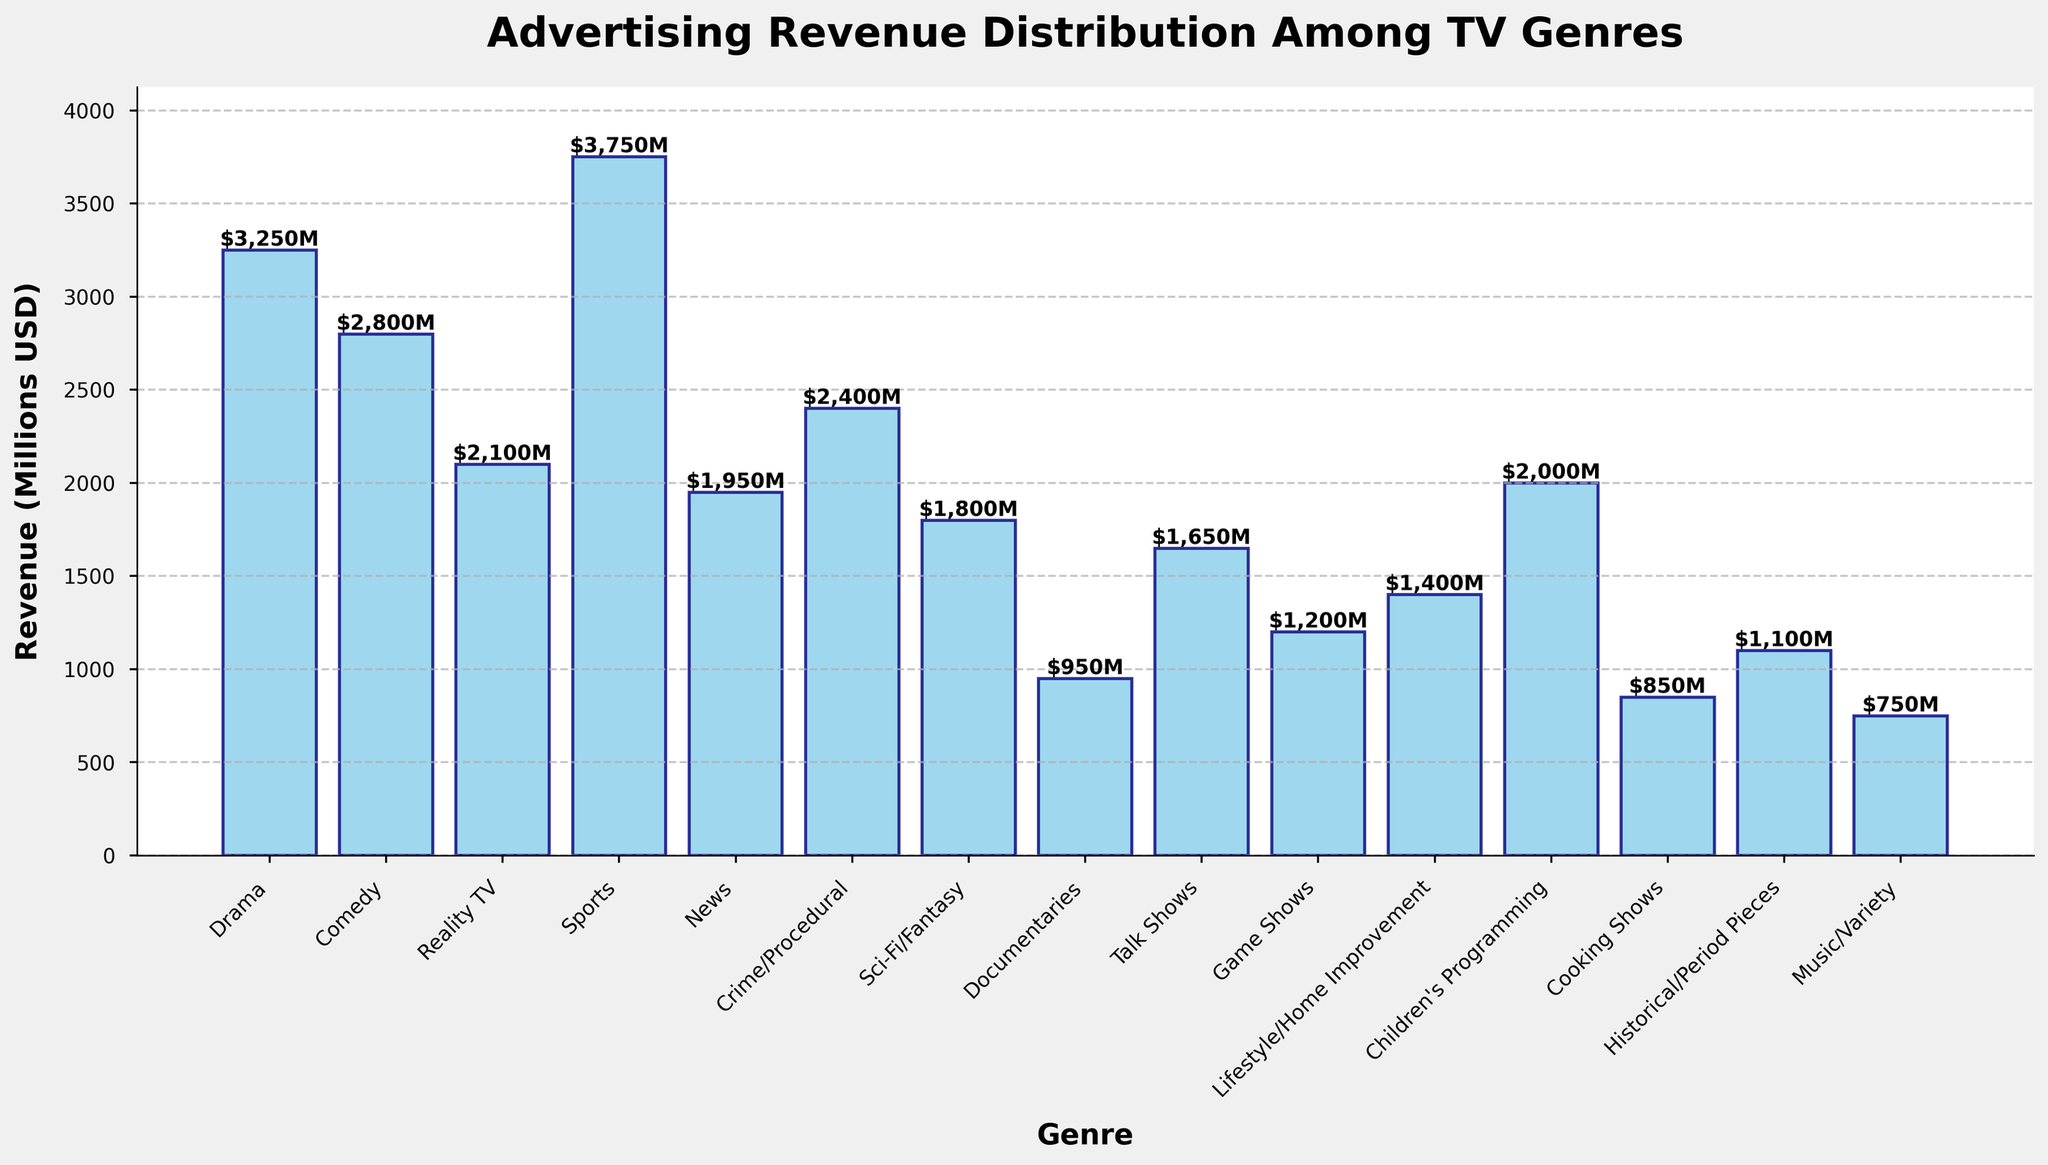Which two genres have the least advertising revenue and how much is it combined? Examining the shortest bars, Music/Variety and Cooking Shows have the least advertising revenue. Adding their values: $750M (Music/Variety) + $850M (Cooking Shows) = $1600M
Answer: Music/Variety and Cooking Shows, $1600M What is the difference in advertising revenue between Crime/Procedural and Children's Programming? Subtract the revenue of Children's Programming ($2000M) from Crime/Procedural ($2400M): $2400M - $2000M = $400M.
Answer: $400M What approximate average advertising revenue is generated by Comedy, Reality TV, and News genres combined? Calculate the sum of the revenues of Comedy ($2800M), Reality TV ($2100M), and News ($1950M) then divide by 3. (2800 + 2100 + 1950) / 3 = $2283.33M.
Answer: $2283.33M What is the total advertising revenue generated by genres with less than $1500M? Identify genres below $1500M and sum their revenues: Documentaries ($950M), Talk Shows ($1650M, excluded), Game Shows ($1200M), Lifestyle/Home Improvement ($1400M), Cooking Shows ($850M), Historical/Period Pieces ($1100M), Music/Variety ($750M). Sum: 950 + 1200 + 1400 + 850 + 1100 + 750 = $6250M.
Answer: $6250M Is the advertising revenue for Sci-Fi/Fantasy higher than that for Talk Shows? Compare the bar heights for Sci-Fi/Fantasy ($1800M) and Talk Shows ($1650M). Sci-Fi/Fantasy has a higher revenue.
Answer: Yes What is the total advertising revenue for Drama, Sports, and News genres? Sum the revenues of Drama ($3250M), Sports ($3750M), and News ($1950M). 3250 + 3750 + 1950 = $8950M.
Answer: $8950M 